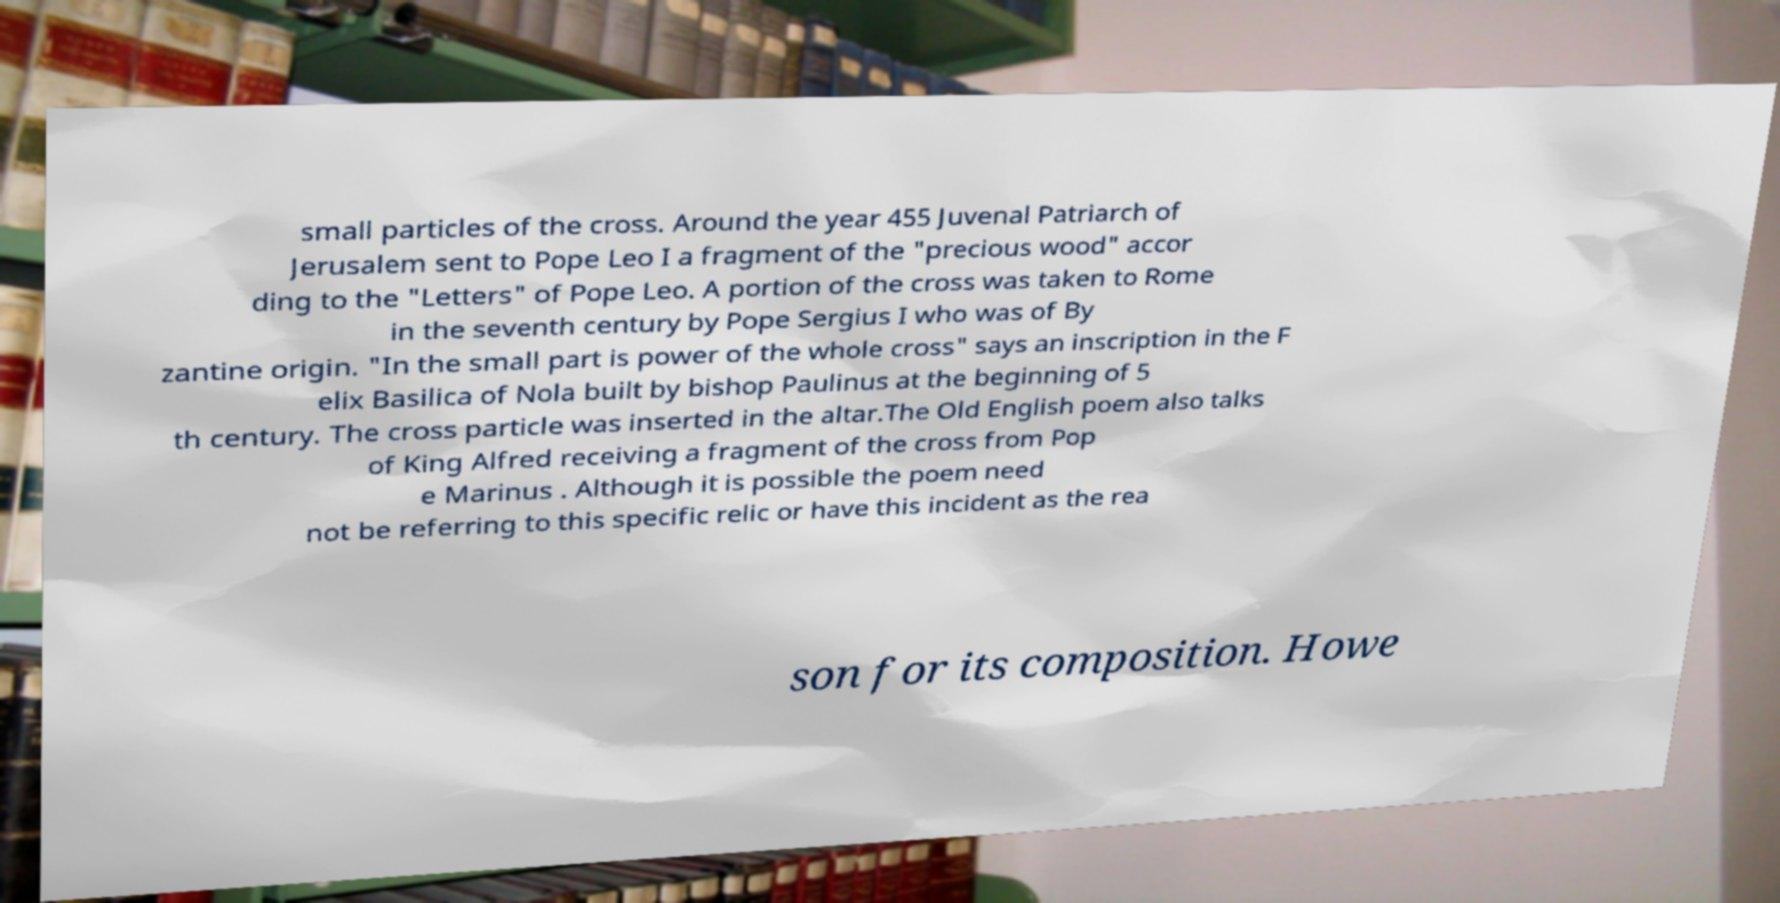For documentation purposes, I need the text within this image transcribed. Could you provide that? small particles of the cross. Around the year 455 Juvenal Patriarch of Jerusalem sent to Pope Leo I a fragment of the "precious wood" accor ding to the "Letters" of Pope Leo. A portion of the cross was taken to Rome in the seventh century by Pope Sergius I who was of By zantine origin. "In the small part is power of the whole cross" says an inscription in the F elix Basilica of Nola built by bishop Paulinus at the beginning of 5 th century. The cross particle was inserted in the altar.The Old English poem also talks of King Alfred receiving a fragment of the cross from Pop e Marinus . Although it is possible the poem need not be referring to this specific relic or have this incident as the rea son for its composition. Howe 